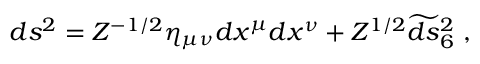Convert formula to latex. <formula><loc_0><loc_0><loc_500><loc_500>d s ^ { 2 } = Z ^ { - 1 / 2 } \eta _ { \mu \nu } d x ^ { \mu } d x ^ { \nu } + Z ^ { 1 / 2 } \widetilde { d s _ { 6 } ^ { 2 } \ ,</formula> 